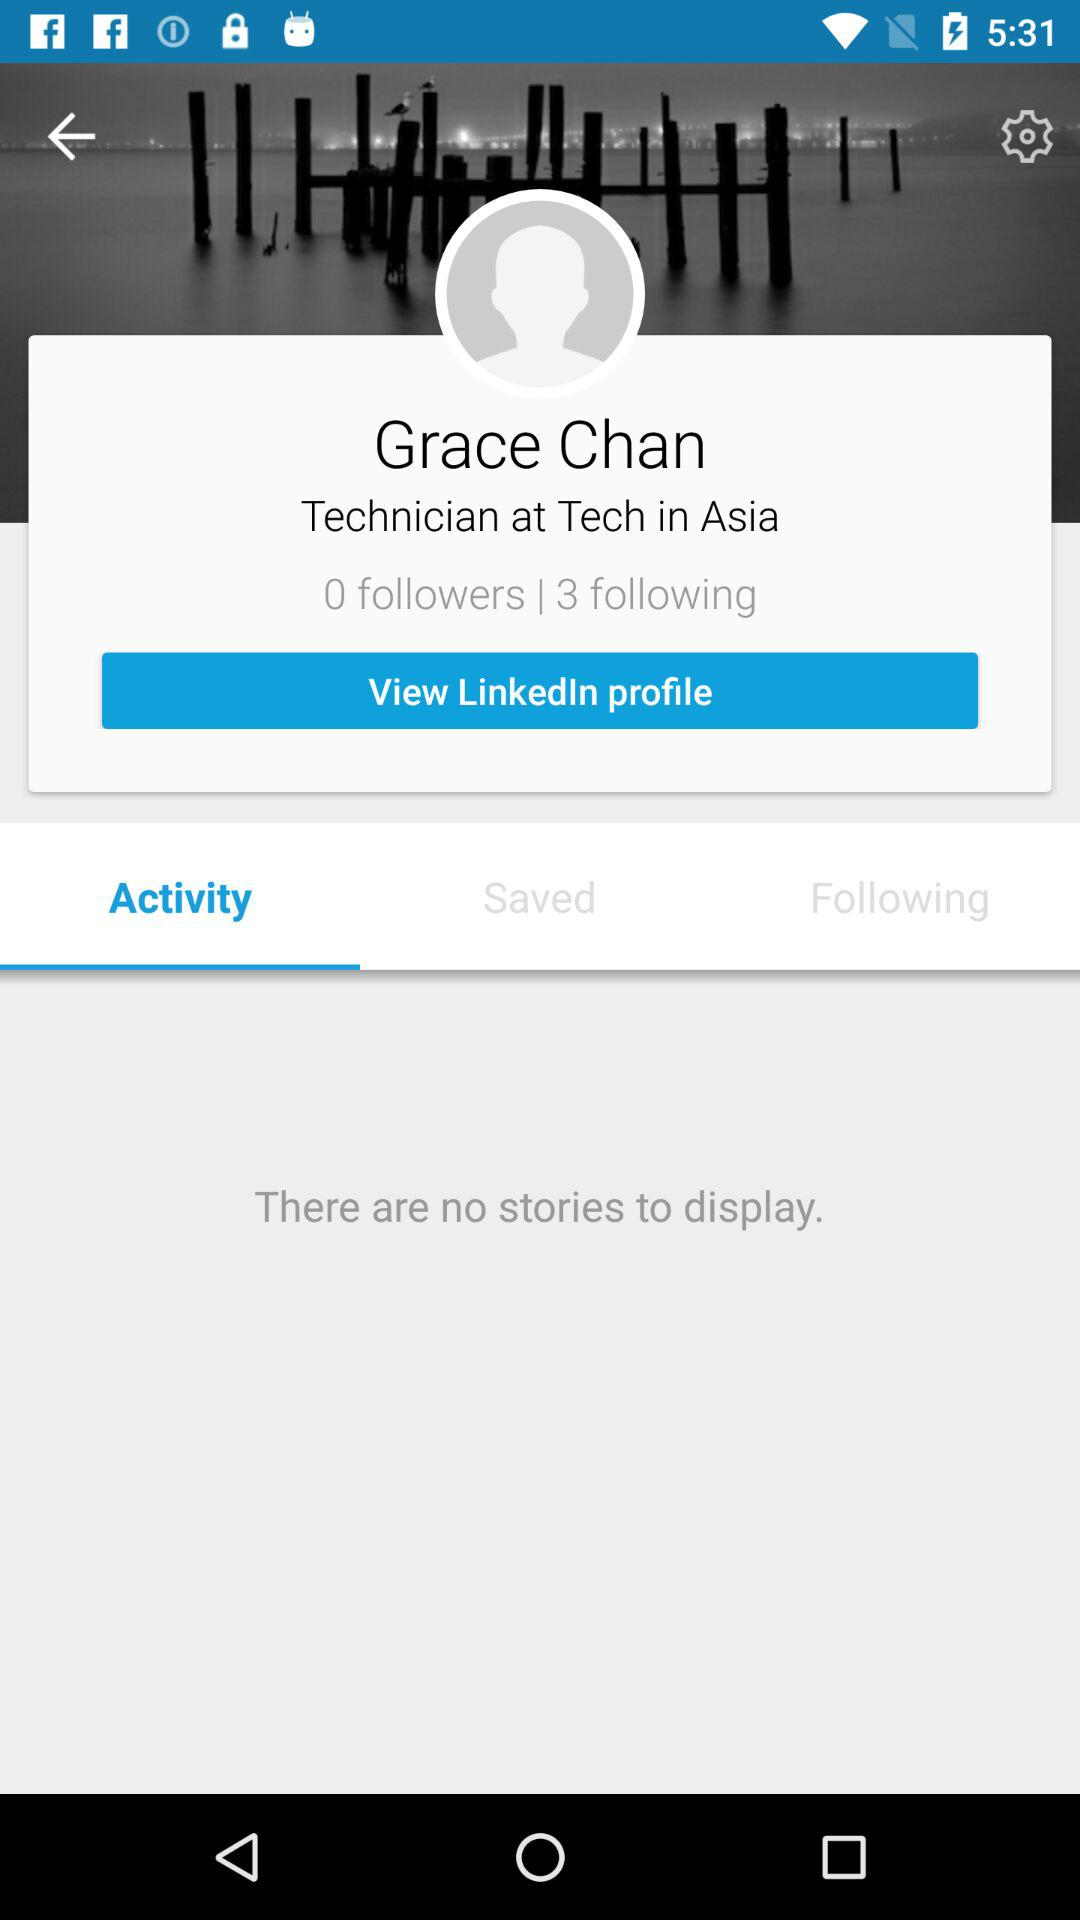Which tab is selected? The selected tab is "Activity". 